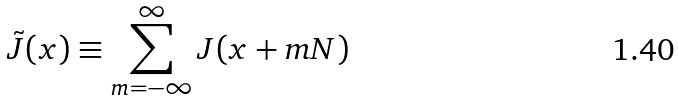<formula> <loc_0><loc_0><loc_500><loc_500>\tilde { J } ( x ) \equiv \sum _ { m = - \infty } ^ { \infty } J ( x + m N )</formula> 